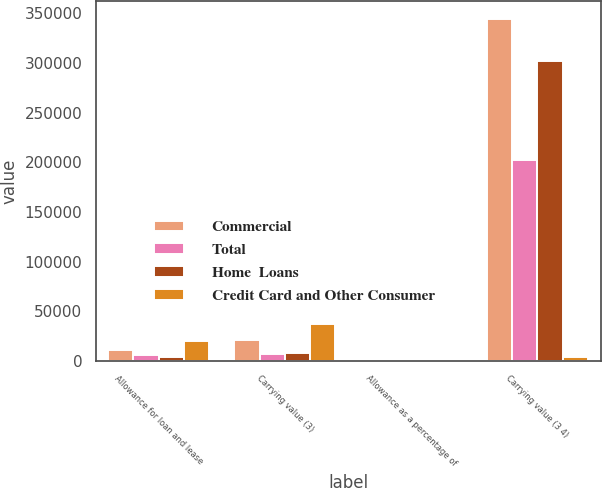<chart> <loc_0><loc_0><loc_500><loc_500><stacked_bar_chart><ecel><fcel>Allowance for loan and lease<fcel>Carrying value (3)<fcel>Allowance as a percentage of<fcel>Carrying value (3 4)<nl><fcel>Commercial<fcel>10674<fcel>21462<fcel>3.1<fcel>344821<nl><fcel>Total<fcel>6159<fcel>7100<fcel>3.05<fcel>202010<nl><fcel>Home  Loans<fcel>3590<fcel>8113<fcel>1.19<fcel>302089<nl><fcel>Credit Card and Other Consumer<fcel>20423<fcel>36675<fcel>2.41<fcel>3590<nl></chart> 